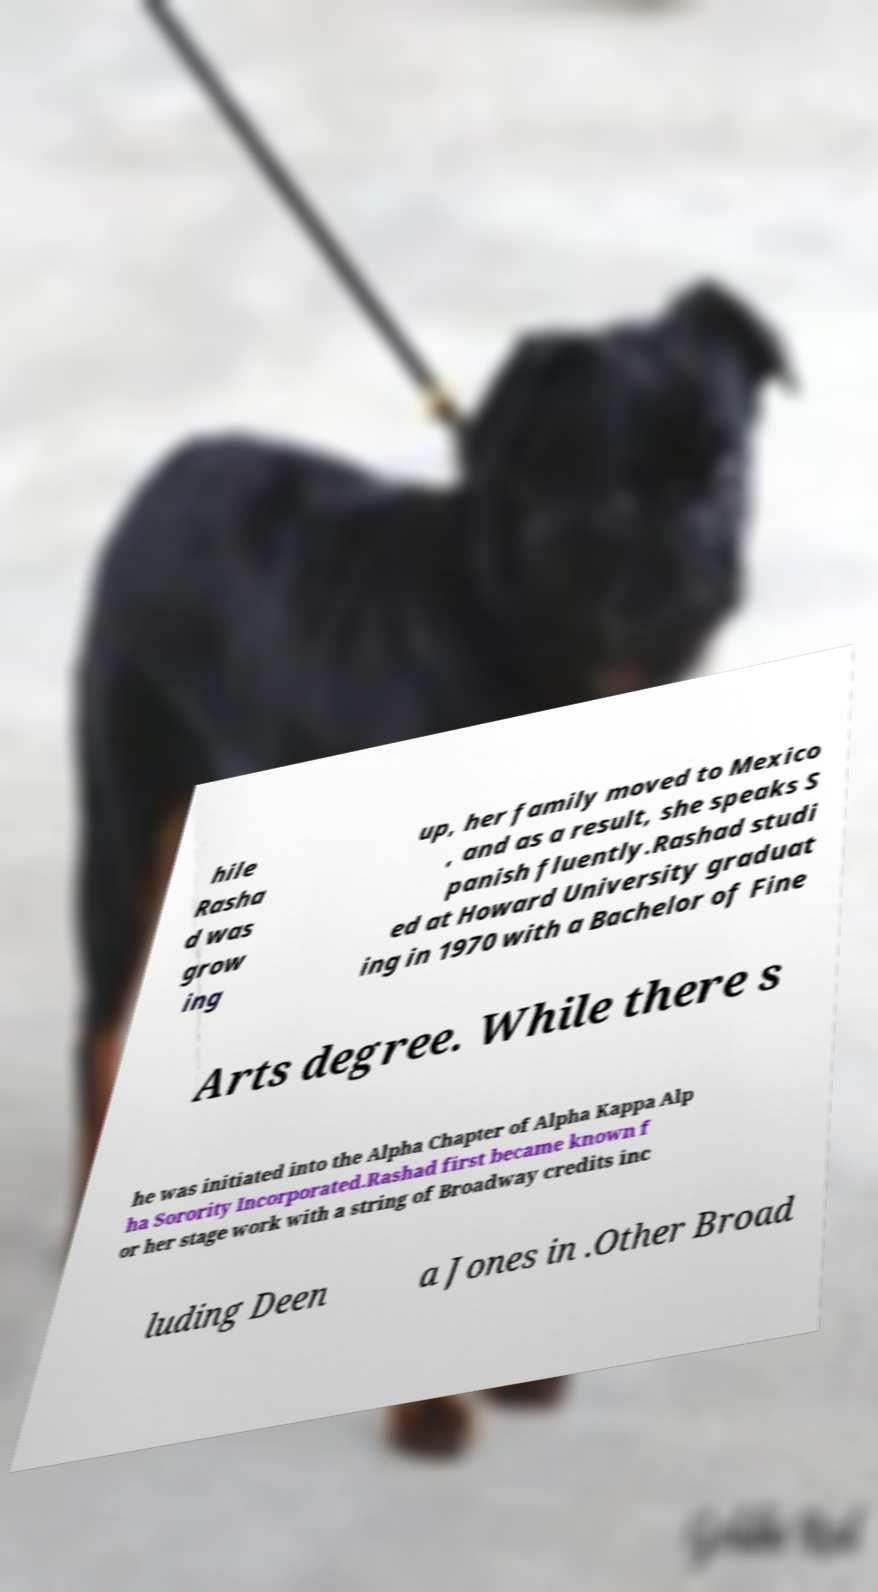What messages or text are displayed in this image? I need them in a readable, typed format. hile Rasha d was grow ing up, her family moved to Mexico , and as a result, she speaks S panish fluently.Rashad studi ed at Howard University graduat ing in 1970 with a Bachelor of Fine Arts degree. While there s he was initiated into the Alpha Chapter of Alpha Kappa Alp ha Sorority Incorporated.Rashad first became known f or her stage work with a string of Broadway credits inc luding Deen a Jones in .Other Broad 